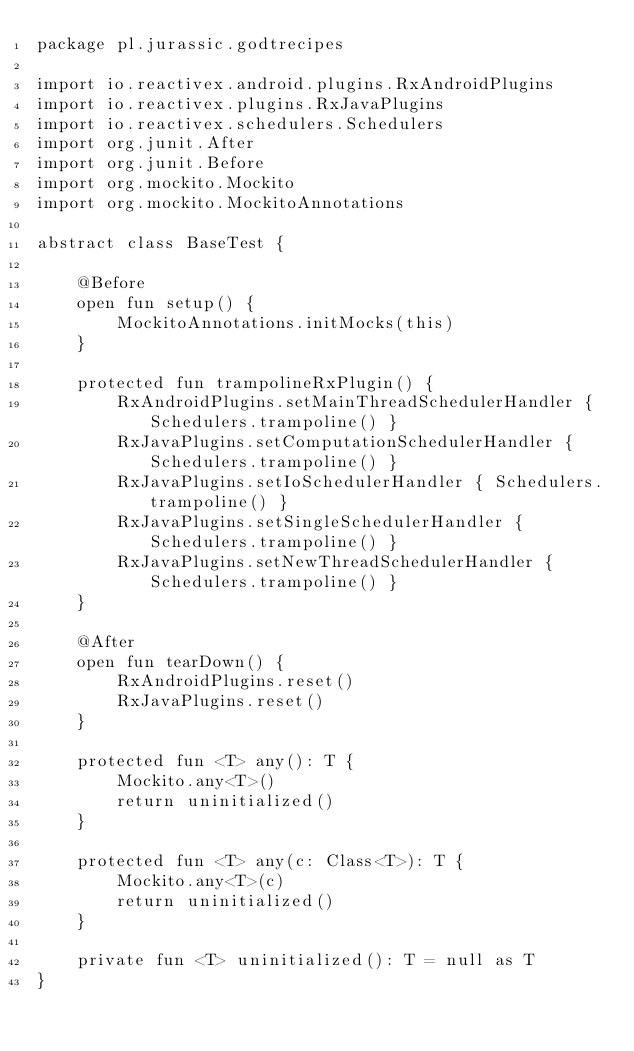Convert code to text. <code><loc_0><loc_0><loc_500><loc_500><_Kotlin_>package pl.jurassic.godtrecipes

import io.reactivex.android.plugins.RxAndroidPlugins
import io.reactivex.plugins.RxJavaPlugins
import io.reactivex.schedulers.Schedulers
import org.junit.After
import org.junit.Before
import org.mockito.Mockito
import org.mockito.MockitoAnnotations

abstract class BaseTest {

    @Before
    open fun setup() {
        MockitoAnnotations.initMocks(this)
    }

    protected fun trampolineRxPlugin() {
        RxAndroidPlugins.setMainThreadSchedulerHandler { Schedulers.trampoline() }
        RxJavaPlugins.setComputationSchedulerHandler { Schedulers.trampoline() }
        RxJavaPlugins.setIoSchedulerHandler { Schedulers.trampoline() }
        RxJavaPlugins.setSingleSchedulerHandler { Schedulers.trampoline() }
        RxJavaPlugins.setNewThreadSchedulerHandler { Schedulers.trampoline() }
    }

    @After
    open fun tearDown() {
        RxAndroidPlugins.reset()
        RxJavaPlugins.reset()
    }

    protected fun <T> any(): T {
        Mockito.any<T>()
        return uninitialized()
    }

    protected fun <T> any(c: Class<T>): T {
        Mockito.any<T>(c)
        return uninitialized()
    }

    private fun <T> uninitialized(): T = null as T
}
</code> 